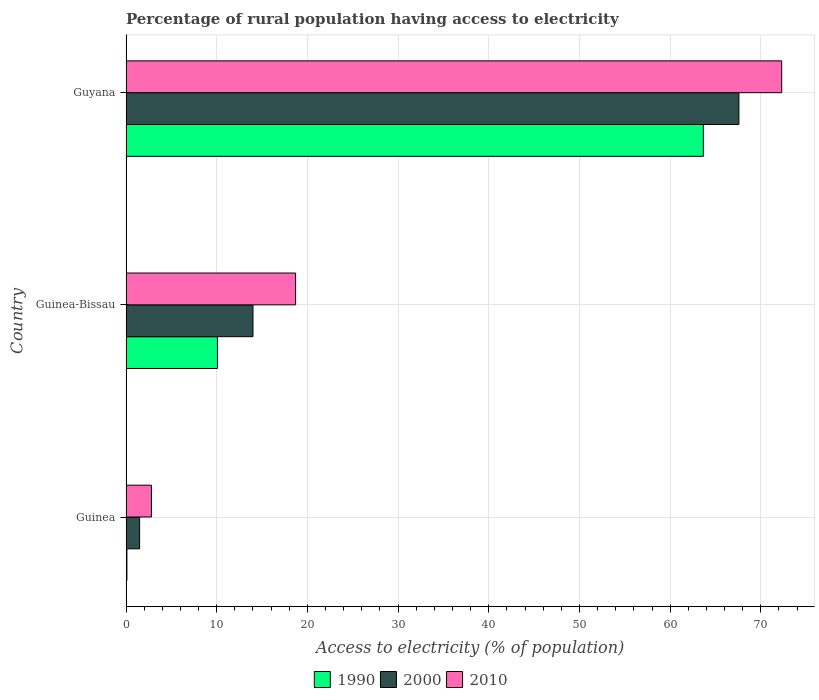How many different coloured bars are there?
Your answer should be very brief. 3. Are the number of bars per tick equal to the number of legend labels?
Your response must be concise. Yes. How many bars are there on the 2nd tick from the top?
Offer a terse response. 3. How many bars are there on the 3rd tick from the bottom?
Your answer should be compact. 3. What is the label of the 3rd group of bars from the top?
Provide a succinct answer. Guinea. What is the percentage of rural population having access to electricity in 1990 in Guinea-Bissau?
Ensure brevity in your answer.  10.08. Across all countries, what is the maximum percentage of rural population having access to electricity in 2000?
Your answer should be compact. 67.58. Across all countries, what is the minimum percentage of rural population having access to electricity in 1990?
Your answer should be compact. 0.1. In which country was the percentage of rural population having access to electricity in 2000 maximum?
Your answer should be compact. Guyana. In which country was the percentage of rural population having access to electricity in 1990 minimum?
Your answer should be very brief. Guinea. What is the total percentage of rural population having access to electricity in 2000 in the graph?
Your answer should be very brief. 83.08. What is the difference between the percentage of rural population having access to electricity in 1990 in Guinea-Bissau and that in Guyana?
Your answer should be very brief. -53.58. What is the average percentage of rural population having access to electricity in 2000 per country?
Make the answer very short. 27.69. What is the difference between the percentage of rural population having access to electricity in 1990 and percentage of rural population having access to electricity in 2010 in Guinea-Bissau?
Give a very brief answer. -8.62. In how many countries, is the percentage of rural population having access to electricity in 2000 greater than 20 %?
Give a very brief answer. 1. What is the ratio of the percentage of rural population having access to electricity in 1990 in Guinea to that in Guyana?
Offer a very short reply. 0. Is the percentage of rural population having access to electricity in 2010 in Guinea-Bissau less than that in Guyana?
Offer a very short reply. Yes. What is the difference between the highest and the second highest percentage of rural population having access to electricity in 1990?
Give a very brief answer. 53.58. What is the difference between the highest and the lowest percentage of rural population having access to electricity in 1990?
Provide a short and direct response. 63.56. Is it the case that in every country, the sum of the percentage of rural population having access to electricity in 1990 and percentage of rural population having access to electricity in 2000 is greater than the percentage of rural population having access to electricity in 2010?
Offer a terse response. No. How many countries are there in the graph?
Your answer should be compact. 3. What is the difference between two consecutive major ticks on the X-axis?
Your answer should be compact. 10. Are the values on the major ticks of X-axis written in scientific E-notation?
Make the answer very short. No. Does the graph contain any zero values?
Provide a short and direct response. No. Where does the legend appear in the graph?
Your answer should be compact. Bottom center. How many legend labels are there?
Offer a very short reply. 3. What is the title of the graph?
Offer a very short reply. Percentage of rural population having access to electricity. Does "1970" appear as one of the legend labels in the graph?
Offer a very short reply. No. What is the label or title of the X-axis?
Your answer should be very brief. Access to electricity (% of population). What is the Access to electricity (% of population) of 1990 in Guinea?
Give a very brief answer. 0.1. What is the Access to electricity (% of population) in 2000 in Guinea?
Offer a terse response. 1.5. What is the Access to electricity (% of population) of 1990 in Guinea-Bissau?
Offer a very short reply. 10.08. What is the Access to electricity (% of population) of 1990 in Guyana?
Your response must be concise. 63.66. What is the Access to electricity (% of population) in 2000 in Guyana?
Ensure brevity in your answer.  67.58. What is the Access to electricity (% of population) in 2010 in Guyana?
Provide a short and direct response. 72.3. Across all countries, what is the maximum Access to electricity (% of population) in 1990?
Ensure brevity in your answer.  63.66. Across all countries, what is the maximum Access to electricity (% of population) in 2000?
Offer a terse response. 67.58. Across all countries, what is the maximum Access to electricity (% of population) in 2010?
Provide a short and direct response. 72.3. Across all countries, what is the minimum Access to electricity (% of population) of 2000?
Your answer should be very brief. 1.5. What is the total Access to electricity (% of population) of 1990 in the graph?
Offer a very short reply. 73.84. What is the total Access to electricity (% of population) of 2000 in the graph?
Give a very brief answer. 83.08. What is the total Access to electricity (% of population) of 2010 in the graph?
Your response must be concise. 93.8. What is the difference between the Access to electricity (% of population) in 1990 in Guinea and that in Guinea-Bissau?
Offer a very short reply. -9.98. What is the difference between the Access to electricity (% of population) in 2000 in Guinea and that in Guinea-Bissau?
Offer a very short reply. -12.5. What is the difference between the Access to electricity (% of population) in 2010 in Guinea and that in Guinea-Bissau?
Keep it short and to the point. -15.9. What is the difference between the Access to electricity (% of population) of 1990 in Guinea and that in Guyana?
Provide a succinct answer. -63.56. What is the difference between the Access to electricity (% of population) of 2000 in Guinea and that in Guyana?
Make the answer very short. -66.08. What is the difference between the Access to electricity (% of population) of 2010 in Guinea and that in Guyana?
Provide a succinct answer. -69.5. What is the difference between the Access to electricity (% of population) in 1990 in Guinea-Bissau and that in Guyana?
Give a very brief answer. -53.58. What is the difference between the Access to electricity (% of population) of 2000 in Guinea-Bissau and that in Guyana?
Make the answer very short. -53.58. What is the difference between the Access to electricity (% of population) of 2010 in Guinea-Bissau and that in Guyana?
Ensure brevity in your answer.  -53.6. What is the difference between the Access to electricity (% of population) of 1990 in Guinea and the Access to electricity (% of population) of 2000 in Guinea-Bissau?
Keep it short and to the point. -13.9. What is the difference between the Access to electricity (% of population) of 1990 in Guinea and the Access to electricity (% of population) of 2010 in Guinea-Bissau?
Make the answer very short. -18.6. What is the difference between the Access to electricity (% of population) of 2000 in Guinea and the Access to electricity (% of population) of 2010 in Guinea-Bissau?
Offer a very short reply. -17.2. What is the difference between the Access to electricity (% of population) of 1990 in Guinea and the Access to electricity (% of population) of 2000 in Guyana?
Your answer should be compact. -67.48. What is the difference between the Access to electricity (% of population) in 1990 in Guinea and the Access to electricity (% of population) in 2010 in Guyana?
Your answer should be compact. -72.2. What is the difference between the Access to electricity (% of population) of 2000 in Guinea and the Access to electricity (% of population) of 2010 in Guyana?
Make the answer very short. -70.8. What is the difference between the Access to electricity (% of population) in 1990 in Guinea-Bissau and the Access to electricity (% of population) in 2000 in Guyana?
Your answer should be very brief. -57.5. What is the difference between the Access to electricity (% of population) of 1990 in Guinea-Bissau and the Access to electricity (% of population) of 2010 in Guyana?
Your answer should be compact. -62.22. What is the difference between the Access to electricity (% of population) in 2000 in Guinea-Bissau and the Access to electricity (% of population) in 2010 in Guyana?
Offer a terse response. -58.3. What is the average Access to electricity (% of population) of 1990 per country?
Keep it short and to the point. 24.61. What is the average Access to electricity (% of population) in 2000 per country?
Provide a succinct answer. 27.69. What is the average Access to electricity (% of population) of 2010 per country?
Give a very brief answer. 31.27. What is the difference between the Access to electricity (% of population) of 2000 and Access to electricity (% of population) of 2010 in Guinea?
Give a very brief answer. -1.3. What is the difference between the Access to electricity (% of population) of 1990 and Access to electricity (% of population) of 2000 in Guinea-Bissau?
Keep it short and to the point. -3.92. What is the difference between the Access to electricity (% of population) in 1990 and Access to electricity (% of population) in 2010 in Guinea-Bissau?
Your answer should be compact. -8.62. What is the difference between the Access to electricity (% of population) of 1990 and Access to electricity (% of population) of 2000 in Guyana?
Offer a terse response. -3.92. What is the difference between the Access to electricity (% of population) in 1990 and Access to electricity (% of population) in 2010 in Guyana?
Your answer should be very brief. -8.64. What is the difference between the Access to electricity (% of population) of 2000 and Access to electricity (% of population) of 2010 in Guyana?
Your answer should be compact. -4.72. What is the ratio of the Access to electricity (% of population) in 1990 in Guinea to that in Guinea-Bissau?
Make the answer very short. 0.01. What is the ratio of the Access to electricity (% of population) in 2000 in Guinea to that in Guinea-Bissau?
Provide a succinct answer. 0.11. What is the ratio of the Access to electricity (% of population) in 2010 in Guinea to that in Guinea-Bissau?
Keep it short and to the point. 0.15. What is the ratio of the Access to electricity (% of population) in 1990 in Guinea to that in Guyana?
Provide a short and direct response. 0. What is the ratio of the Access to electricity (% of population) in 2000 in Guinea to that in Guyana?
Give a very brief answer. 0.02. What is the ratio of the Access to electricity (% of population) in 2010 in Guinea to that in Guyana?
Offer a terse response. 0.04. What is the ratio of the Access to electricity (% of population) of 1990 in Guinea-Bissau to that in Guyana?
Offer a terse response. 0.16. What is the ratio of the Access to electricity (% of population) of 2000 in Guinea-Bissau to that in Guyana?
Give a very brief answer. 0.21. What is the ratio of the Access to electricity (% of population) of 2010 in Guinea-Bissau to that in Guyana?
Make the answer very short. 0.26. What is the difference between the highest and the second highest Access to electricity (% of population) in 1990?
Your answer should be very brief. 53.58. What is the difference between the highest and the second highest Access to electricity (% of population) in 2000?
Your answer should be compact. 53.58. What is the difference between the highest and the second highest Access to electricity (% of population) in 2010?
Provide a succinct answer. 53.6. What is the difference between the highest and the lowest Access to electricity (% of population) of 1990?
Make the answer very short. 63.56. What is the difference between the highest and the lowest Access to electricity (% of population) of 2000?
Keep it short and to the point. 66.08. What is the difference between the highest and the lowest Access to electricity (% of population) of 2010?
Provide a succinct answer. 69.5. 